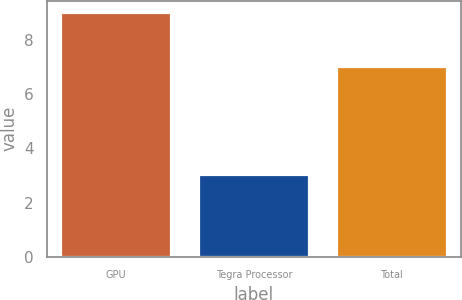Convert chart. <chart><loc_0><loc_0><loc_500><loc_500><bar_chart><fcel>GPU<fcel>Tegra Processor<fcel>Total<nl><fcel>9<fcel>3<fcel>7<nl></chart> 